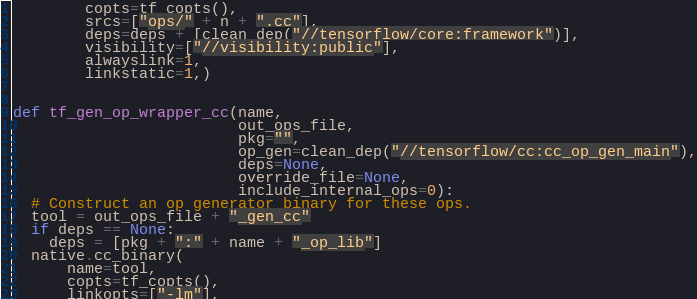<code> <loc_0><loc_0><loc_500><loc_500><_Python_>        copts=tf_copts(),
        srcs=["ops/" + n + ".cc"],
        deps=deps + [clean_dep("//tensorflow/core:framework")],
        visibility=["//visibility:public"],
        alwayslink=1,
        linkstatic=1,)


def tf_gen_op_wrapper_cc(name,
                         out_ops_file,
                         pkg="",
                         op_gen=clean_dep("//tensorflow/cc:cc_op_gen_main"),
                         deps=None,
                         override_file=None,
                         include_internal_ops=0):
  # Construct an op generator binary for these ops.
  tool = out_ops_file + "_gen_cc"
  if deps == None:
    deps = [pkg + ":" + name + "_op_lib"]
  native.cc_binary(
      name=tool,
      copts=tf_copts(),
      linkopts=["-lm"],</code> 